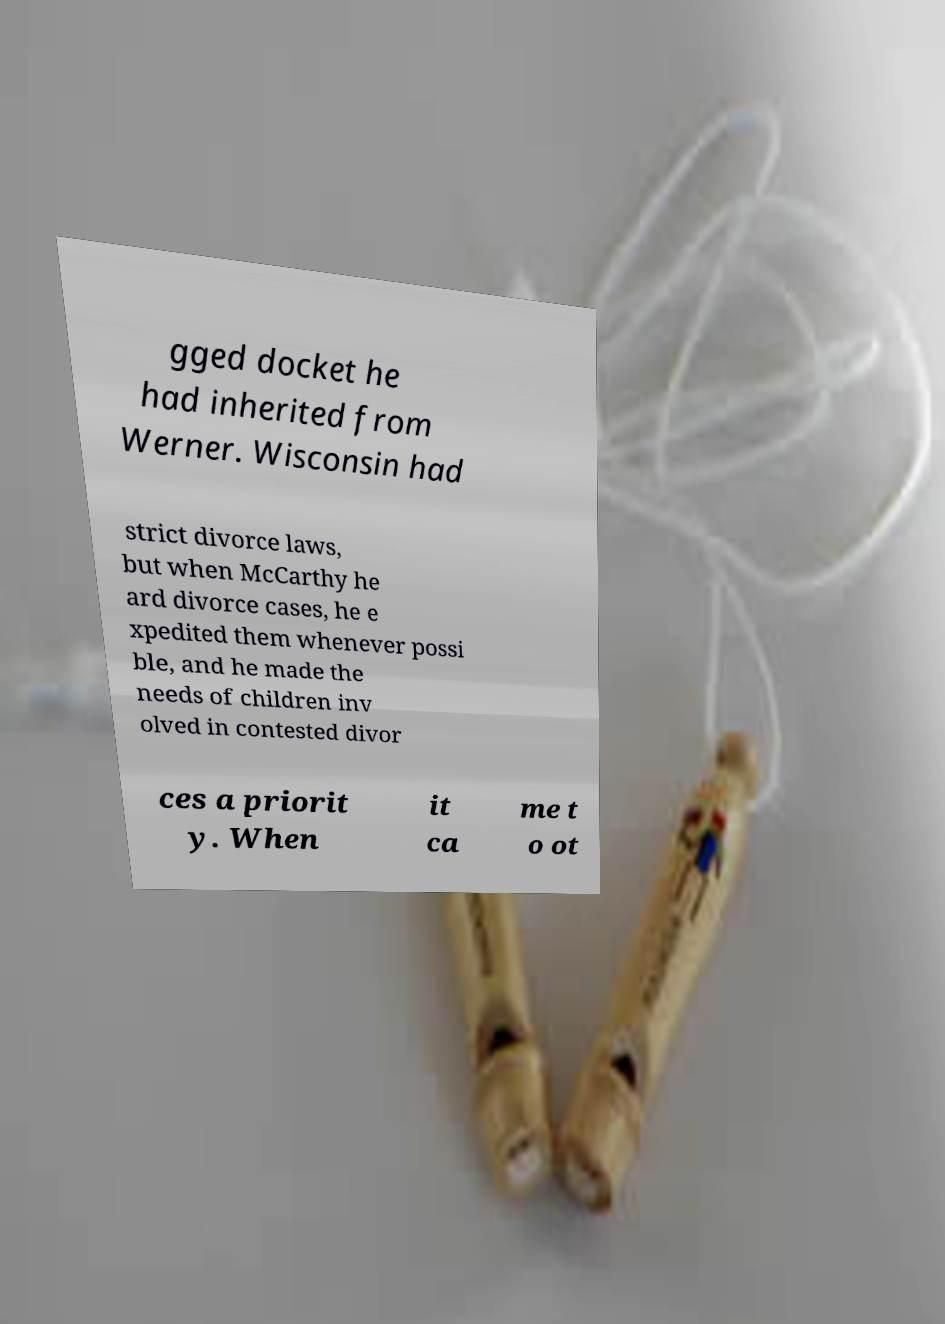What messages or text are displayed in this image? I need them in a readable, typed format. gged docket he had inherited from Werner. Wisconsin had strict divorce laws, but when McCarthy he ard divorce cases, he e xpedited them whenever possi ble, and he made the needs of children inv olved in contested divor ces a priorit y. When it ca me t o ot 